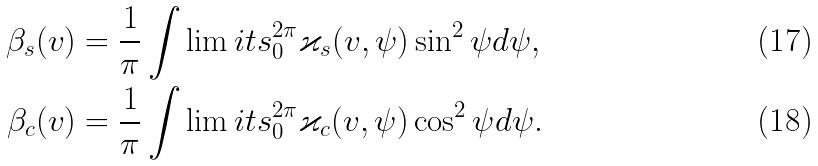<formula> <loc_0><loc_0><loc_500><loc_500>\beta _ { s } ( v ) & = \frac { 1 } { \pi } \int \lim i t s _ { 0 } ^ { 2 \pi } \varkappa _ { s } ( v , \psi ) \sin ^ { 2 } \psi d \psi , \\ \beta _ { c } ( v ) & = \frac { 1 } { \pi } \int \lim i t s _ { 0 } ^ { 2 \pi } \varkappa _ { c } ( v , \psi ) \cos ^ { 2 } \psi d \psi .</formula> 